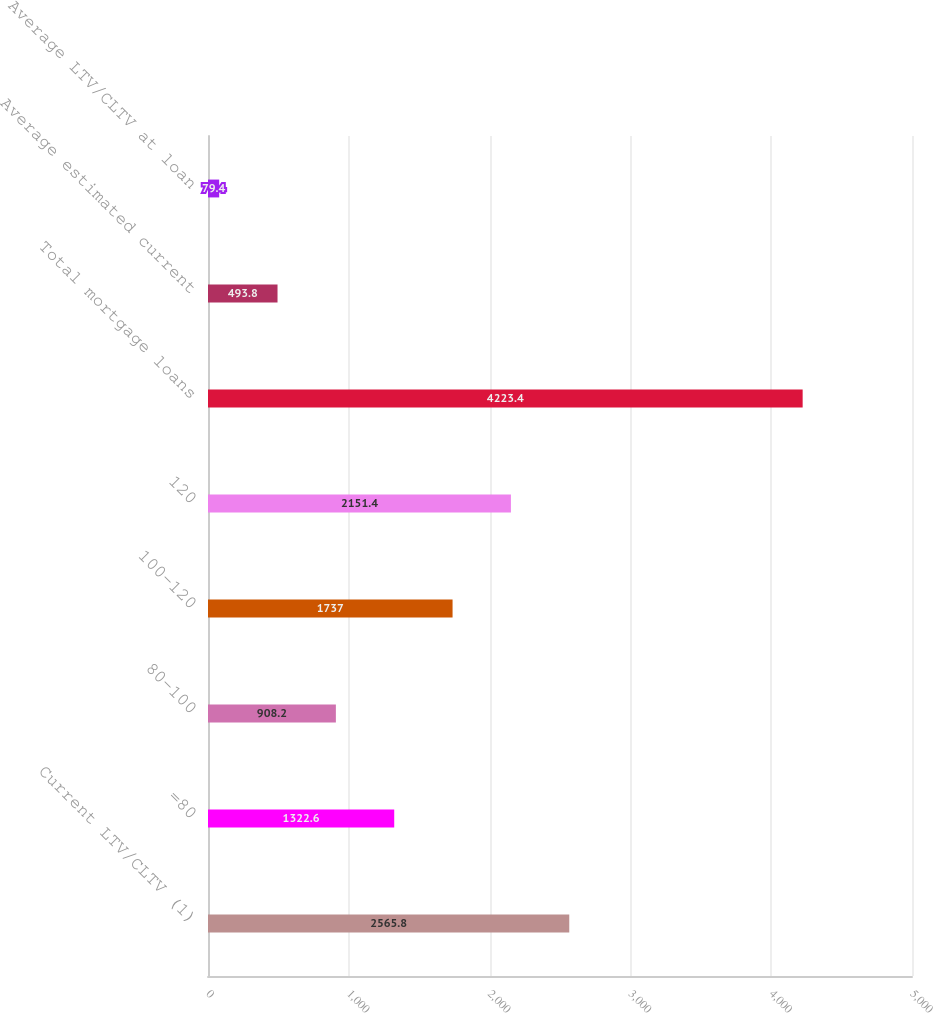Convert chart to OTSL. <chart><loc_0><loc_0><loc_500><loc_500><bar_chart><fcel>Current LTV/CLTV (1)<fcel>=80<fcel>80-100<fcel>100-120<fcel>120<fcel>Total mortgage loans<fcel>Average estimated current<fcel>Average LTV/CLTV at loan<nl><fcel>2565.8<fcel>1322.6<fcel>908.2<fcel>1737<fcel>2151.4<fcel>4223.4<fcel>493.8<fcel>79.4<nl></chart> 